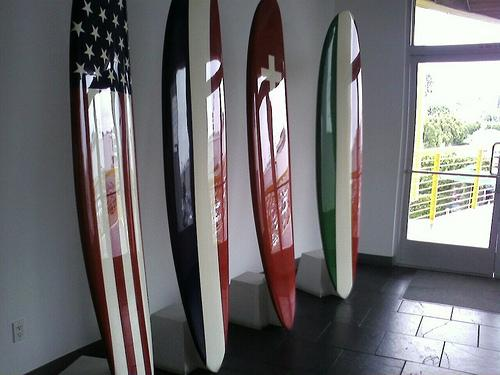What theme seems to have inspired the painting of the surfboards? Please explain your reasoning. countries. Surfboards are all painted in red, white, and blue. the american flag is red, white, and blue. 